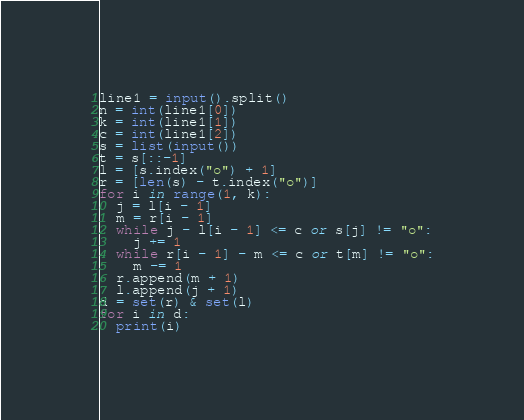<code> <loc_0><loc_0><loc_500><loc_500><_Python_>line1 = input().split()
n = int(line1[0])
k = int(line1[1])
c = int(line1[2])
s = list(input())
t = s[::-1]
l = [s.index("o") + 1]
r = [len(s) - t.index("o")]
for i in range(1, k):
  j = l[i - 1]
  m = r[i - 1]
  while j - l[i - 1] <= c or s[j] != "o":
    j += 1
  while r[i - 1] - m <= c or t[m] != "o":
    m -= 1
  r.append(m + 1)
  l.append(j + 1)
d = set(r) & set(l)
for i in d:
  print(i)</code> 